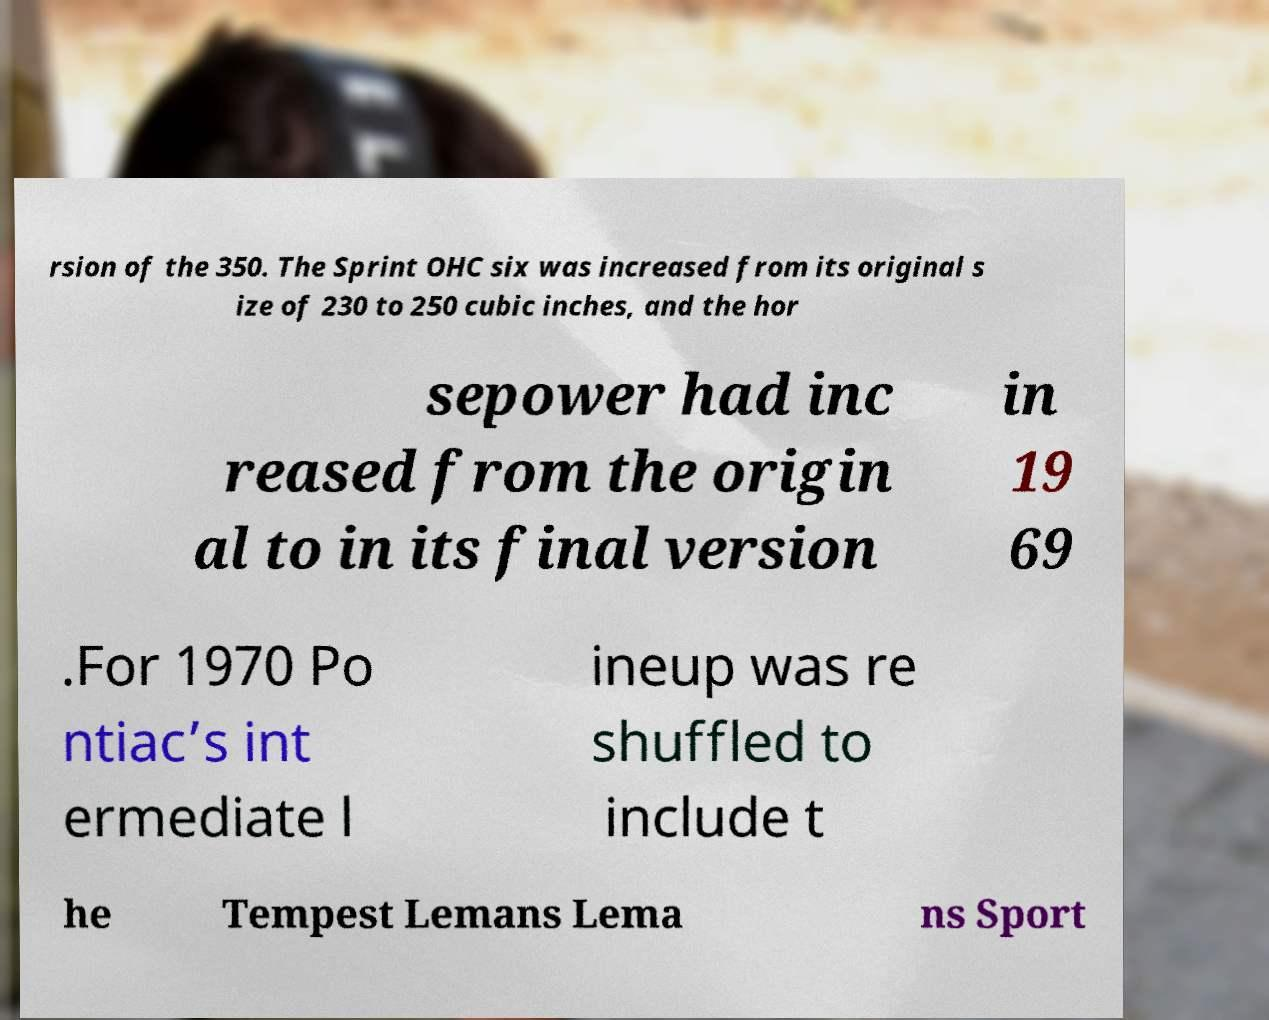Please read and relay the text visible in this image. What does it say? rsion of the 350. The Sprint OHC six was increased from its original s ize of 230 to 250 cubic inches, and the hor sepower had inc reased from the origin al to in its final version in 19 69 .For 1970 Po ntiac’s int ermediate l ineup was re shuffled to include t he Tempest Lemans Lema ns Sport 